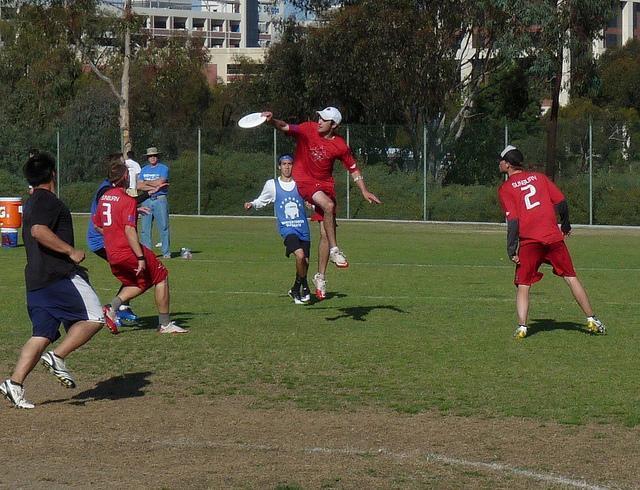What company has trademarked the popular name of this toy?
Pick the right solution, then justify: 'Answer: answer
Rationale: rationale.'
Options: Fisher price, wham-o, hasbro, mattel. Answer: wham-o.
Rationale: It is a frisbee. 